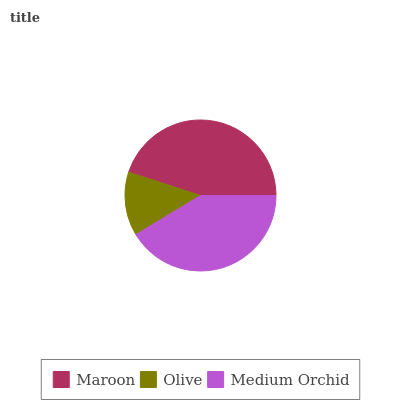Is Olive the minimum?
Answer yes or no. Yes. Is Maroon the maximum?
Answer yes or no. Yes. Is Medium Orchid the minimum?
Answer yes or no. No. Is Medium Orchid the maximum?
Answer yes or no. No. Is Medium Orchid greater than Olive?
Answer yes or no. Yes. Is Olive less than Medium Orchid?
Answer yes or no. Yes. Is Olive greater than Medium Orchid?
Answer yes or no. No. Is Medium Orchid less than Olive?
Answer yes or no. No. Is Medium Orchid the high median?
Answer yes or no. Yes. Is Medium Orchid the low median?
Answer yes or no. Yes. Is Maroon the high median?
Answer yes or no. No. Is Olive the low median?
Answer yes or no. No. 